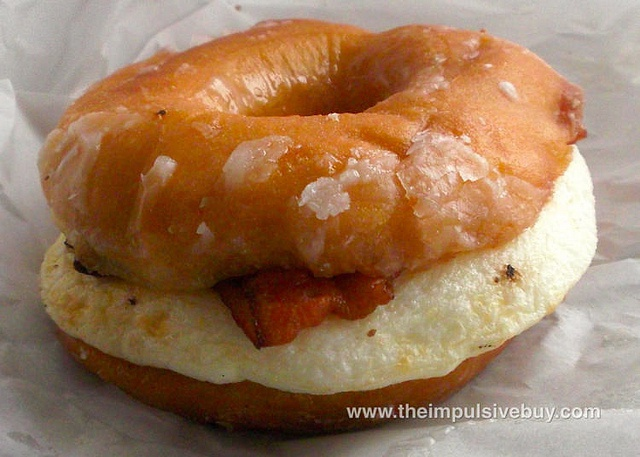Describe the objects in this image and their specific colors. I can see sandwich in darkgray, maroon, brown, and tan tones and donut in darkgray, maroon, brown, tan, and black tones in this image. 